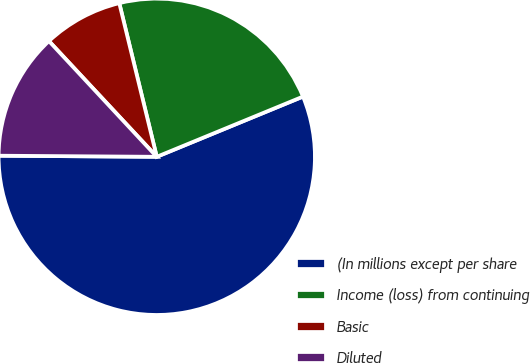Convert chart to OTSL. <chart><loc_0><loc_0><loc_500><loc_500><pie_chart><fcel>(In millions except per share<fcel>Income (loss) from continuing<fcel>Basic<fcel>Diluted<nl><fcel>56.32%<fcel>22.59%<fcel>8.13%<fcel>12.95%<nl></chart> 